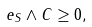<formula> <loc_0><loc_0><loc_500><loc_500>e _ { S } \wedge C \geq 0 ,</formula> 